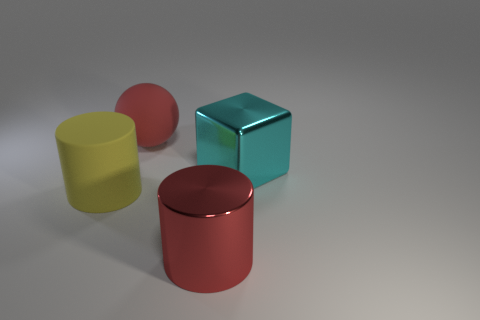Add 1 big metallic cylinders. How many objects exist? 5 Subtract all blocks. How many objects are left? 3 Subtract all large red metal cylinders. Subtract all big cyan cubes. How many objects are left? 2 Add 1 big cyan shiny blocks. How many big cyan shiny blocks are left? 2 Add 1 cyan cubes. How many cyan cubes exist? 2 Subtract 0 brown cylinders. How many objects are left? 4 